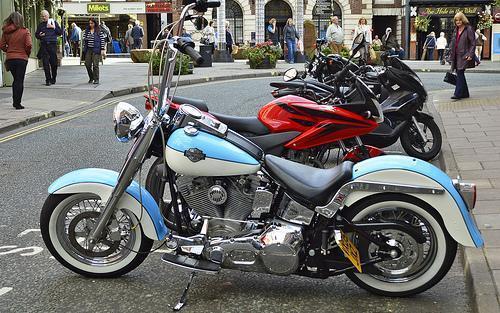How many motorcycles are there?
Give a very brief answer. 4. 